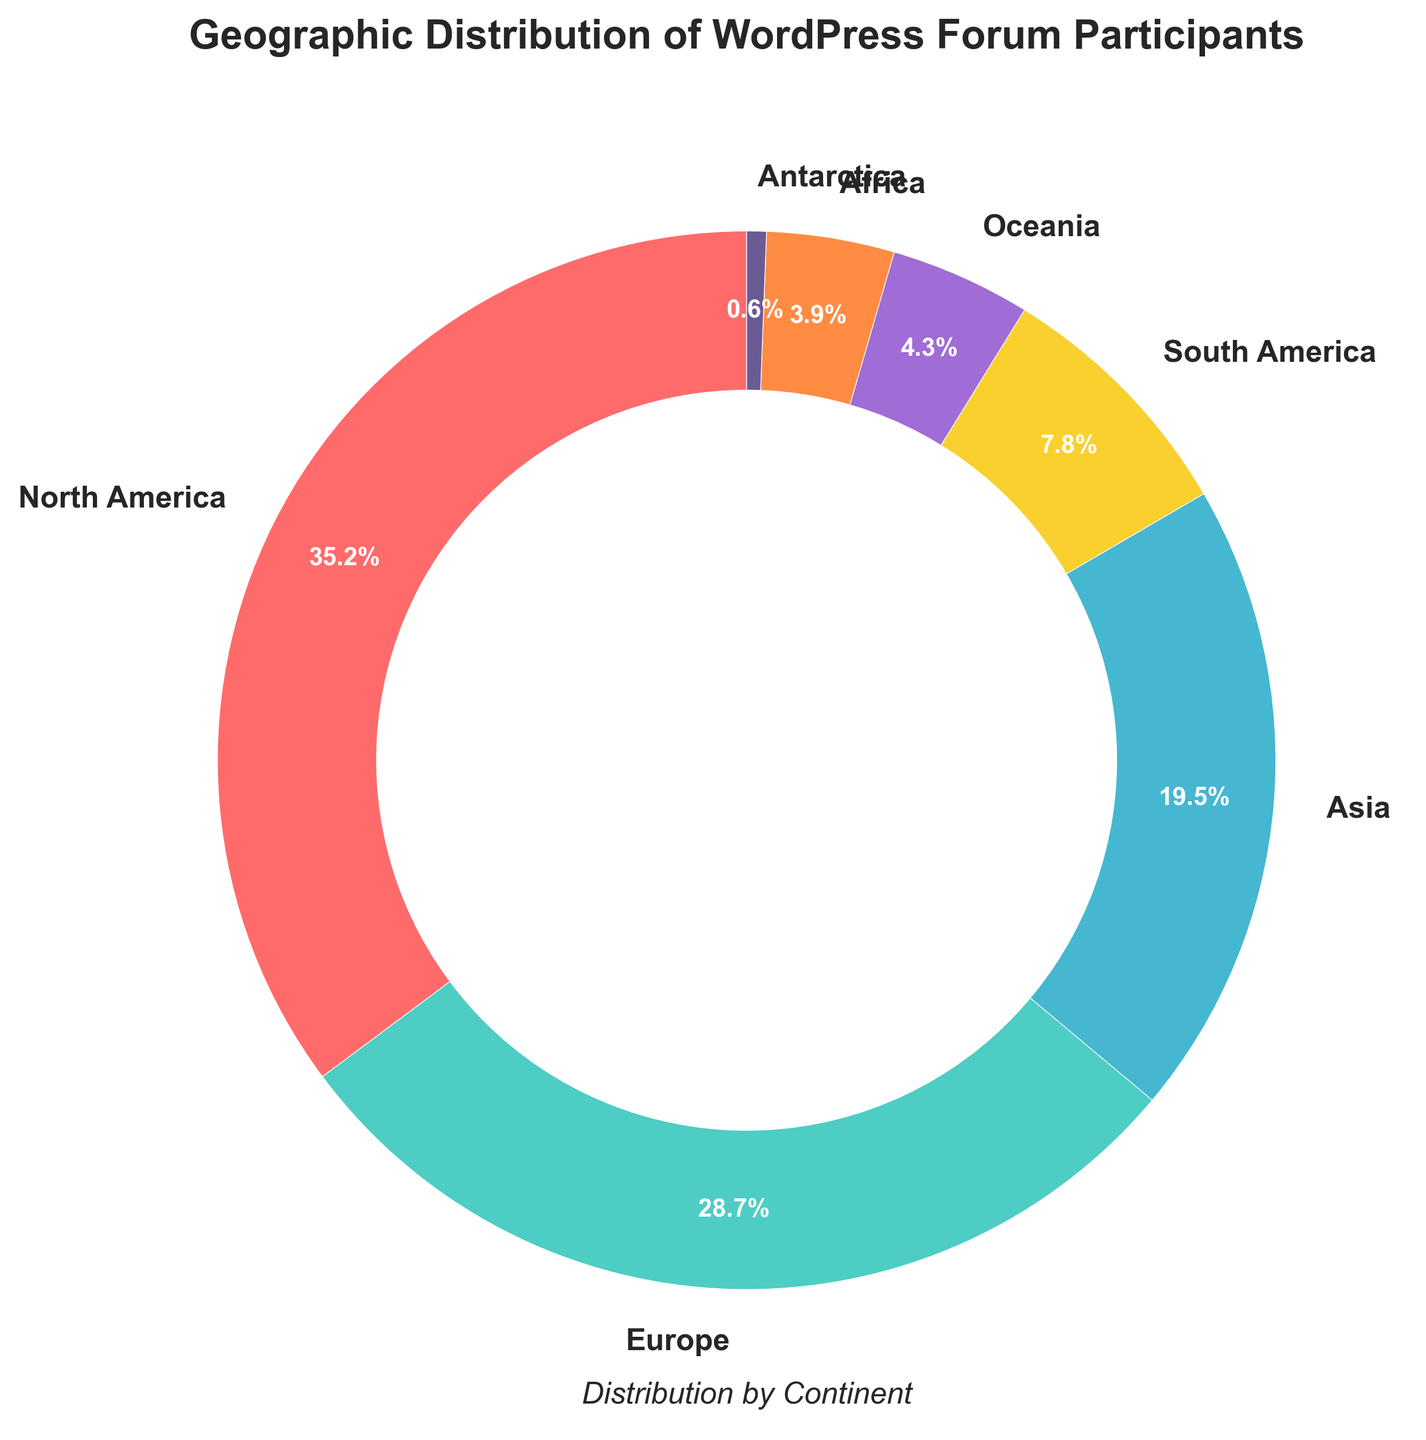What percentage of WordPress forum participants are from Europe? Look at the pie chart and find the segment labeled "Europe". The percentage is displayed next to the label.
Answer: 28.7% Which continent has the smallest percentage of WordPress forum participants? Identify the smallest segment in the pie chart. The label beside this segment shows "Antarctica".
Answer: Antarctica What is the combined percentage of participants from North America and Europe? Find the percentages for North America (35.2%) and Europe (28.7%). Add them together: 35.2 + 28.7 = 63.9
Answer: 63.9% How many continents have less than 10% of the participants? Count the segments in the pie chart where the percentage is less than 10%. These include South America (7.8%), Oceania (4.3%), Africa (3.9%), and Antarctica (0.6%).
Answer: 4 Which continent's segment is colored red, and what percentage does it represent? Identify the segment that is colored red in the pie chart. The label next to this segment shows "North America".
Answer: North America, 35.2% Is the percentage of participants from Asia greater or less than that from Europe? Compare the percentages shown next to "Asia" (19.5%) and "Europe" (28.7%).
Answer: Less What is the difference in percentage between participants from South America and Oceania? Subtract the percentage for Oceania (4.3%) from the percentage for South America (7.8%): 7.8 - 4.3 = 3.5
Answer: 3.5% Which two continents have the closest percentages of participants? Compare the percentages of all continents and find the two closest to each other. Africa (3.9%) and Oceania (4.3%) are the closest.
Answer: Africa and Oceania What proportion of the total participants does the largest segment represent? Find the segment with the largest percentage, which is North America (35.2%). Since 100% represents the whole, the proportion is 35.2/100 = 0.352
Answer: 0.352 